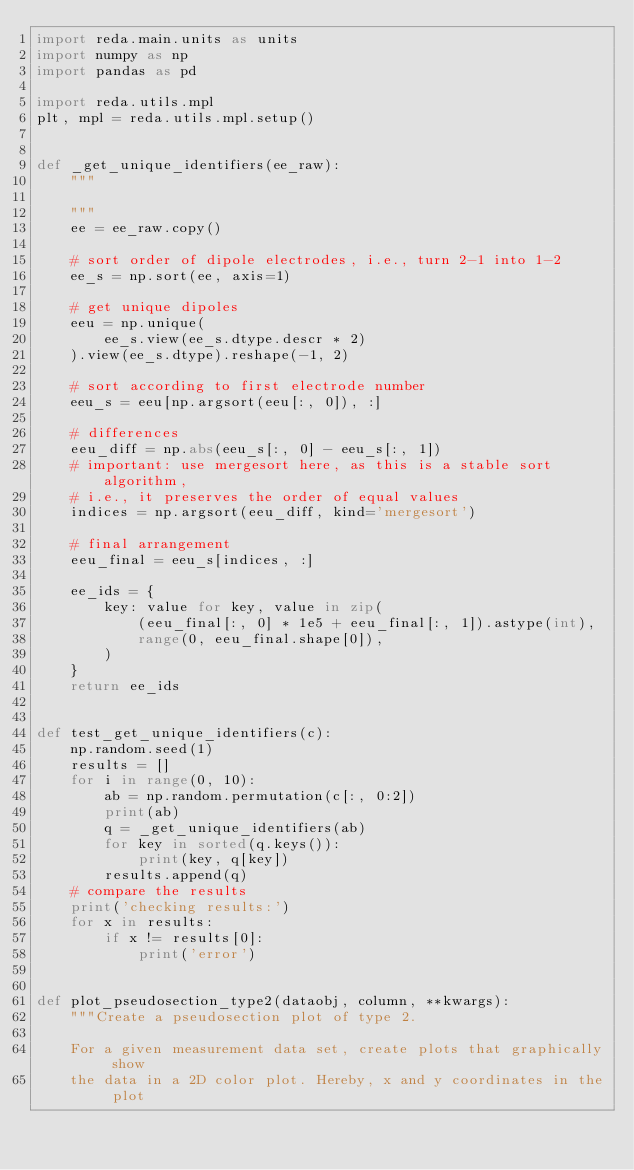Convert code to text. <code><loc_0><loc_0><loc_500><loc_500><_Python_>import reda.main.units as units
import numpy as np
import pandas as pd

import reda.utils.mpl
plt, mpl = reda.utils.mpl.setup()


def _get_unique_identifiers(ee_raw):
    """

    """
    ee = ee_raw.copy()

    # sort order of dipole electrodes, i.e., turn 2-1 into 1-2
    ee_s = np.sort(ee, axis=1)

    # get unique dipoles
    eeu = np.unique(
        ee_s.view(ee_s.dtype.descr * 2)
    ).view(ee_s.dtype).reshape(-1, 2)

    # sort according to first electrode number
    eeu_s = eeu[np.argsort(eeu[:, 0]), :]

    # differences
    eeu_diff = np.abs(eeu_s[:, 0] - eeu_s[:, 1])
    # important: use mergesort here, as this is a stable sort algorithm,
    # i.e., it preserves the order of equal values
    indices = np.argsort(eeu_diff, kind='mergesort')

    # final arrangement
    eeu_final = eeu_s[indices, :]

    ee_ids = {
        key: value for key, value in zip(
            (eeu_final[:, 0] * 1e5 + eeu_final[:, 1]).astype(int),
            range(0, eeu_final.shape[0]),
        )
    }
    return ee_ids


def test_get_unique_identifiers(c):
    np.random.seed(1)
    results = []
    for i in range(0, 10):
        ab = np.random.permutation(c[:, 0:2])
        print(ab)
        q = _get_unique_identifiers(ab)
        for key in sorted(q.keys()):
            print(key, q[key])
        results.append(q)
    # compare the results
    print('checking results:')
    for x in results:
        if x != results[0]:
            print('error')


def plot_pseudosection_type2(dataobj, column, **kwargs):
    """Create a pseudosection plot of type 2.

    For a given measurement data set, create plots that graphically show
    the data in a 2D color plot. Hereby, x and y coordinates in the plot</code> 